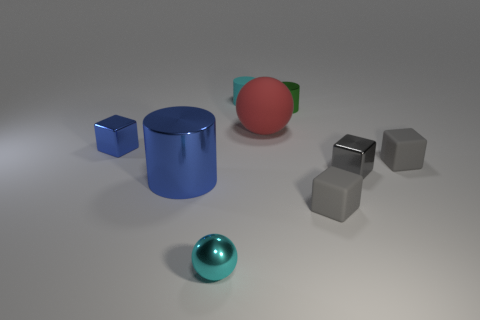There is a thing that is the same color as the tiny shiny ball; what shape is it?
Provide a succinct answer. Cylinder. What is the color of the ball that is behind the small block in front of the cylinder that is in front of the large red sphere?
Your answer should be very brief. Red. What number of other small things are the same shape as the red rubber thing?
Your answer should be compact. 1. There is a cube to the left of the tiny gray rubber block in front of the blue cylinder; how big is it?
Keep it short and to the point. Small. Does the cyan rubber thing have the same size as the metallic ball?
Offer a very short reply. Yes. Are there any red spheres that are to the right of the ball right of the cyan thing behind the large red sphere?
Provide a succinct answer. No. What size is the red object?
Offer a terse response. Large. How many rubber things are the same size as the blue metallic cylinder?
Provide a succinct answer. 1. What material is the tiny cyan thing that is the same shape as the large red rubber thing?
Ensure brevity in your answer.  Metal. There is a small metallic object that is right of the big rubber ball and in front of the small green shiny thing; what is its shape?
Keep it short and to the point. Cube. 